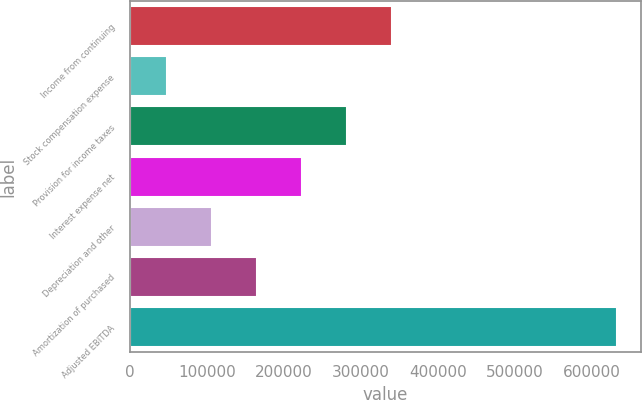Convert chart to OTSL. <chart><loc_0><loc_0><loc_500><loc_500><bar_chart><fcel>Income from continuing<fcel>Stock compensation expense<fcel>Provision for income taxes<fcel>Interest expense net<fcel>Depreciation and other<fcel>Amortization of purchased<fcel>Adjusted EBITDA<nl><fcel>340248<fcel>48311<fcel>281861<fcel>223473<fcel>106698<fcel>165086<fcel>632185<nl></chart> 